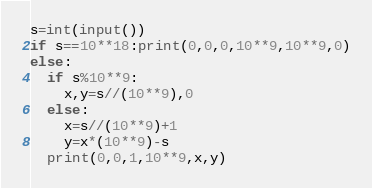<code> <loc_0><loc_0><loc_500><loc_500><_Python_>s=int(input())
if s==10**18:print(0,0,0,10**9,10**9,0)
else:
  if s%10**9:
    x,y=s//(10**9),0
  else:
    x=s//(10**9)+1
    y=x*(10**9)-s
  print(0,0,1,10**9,x,y)</code> 